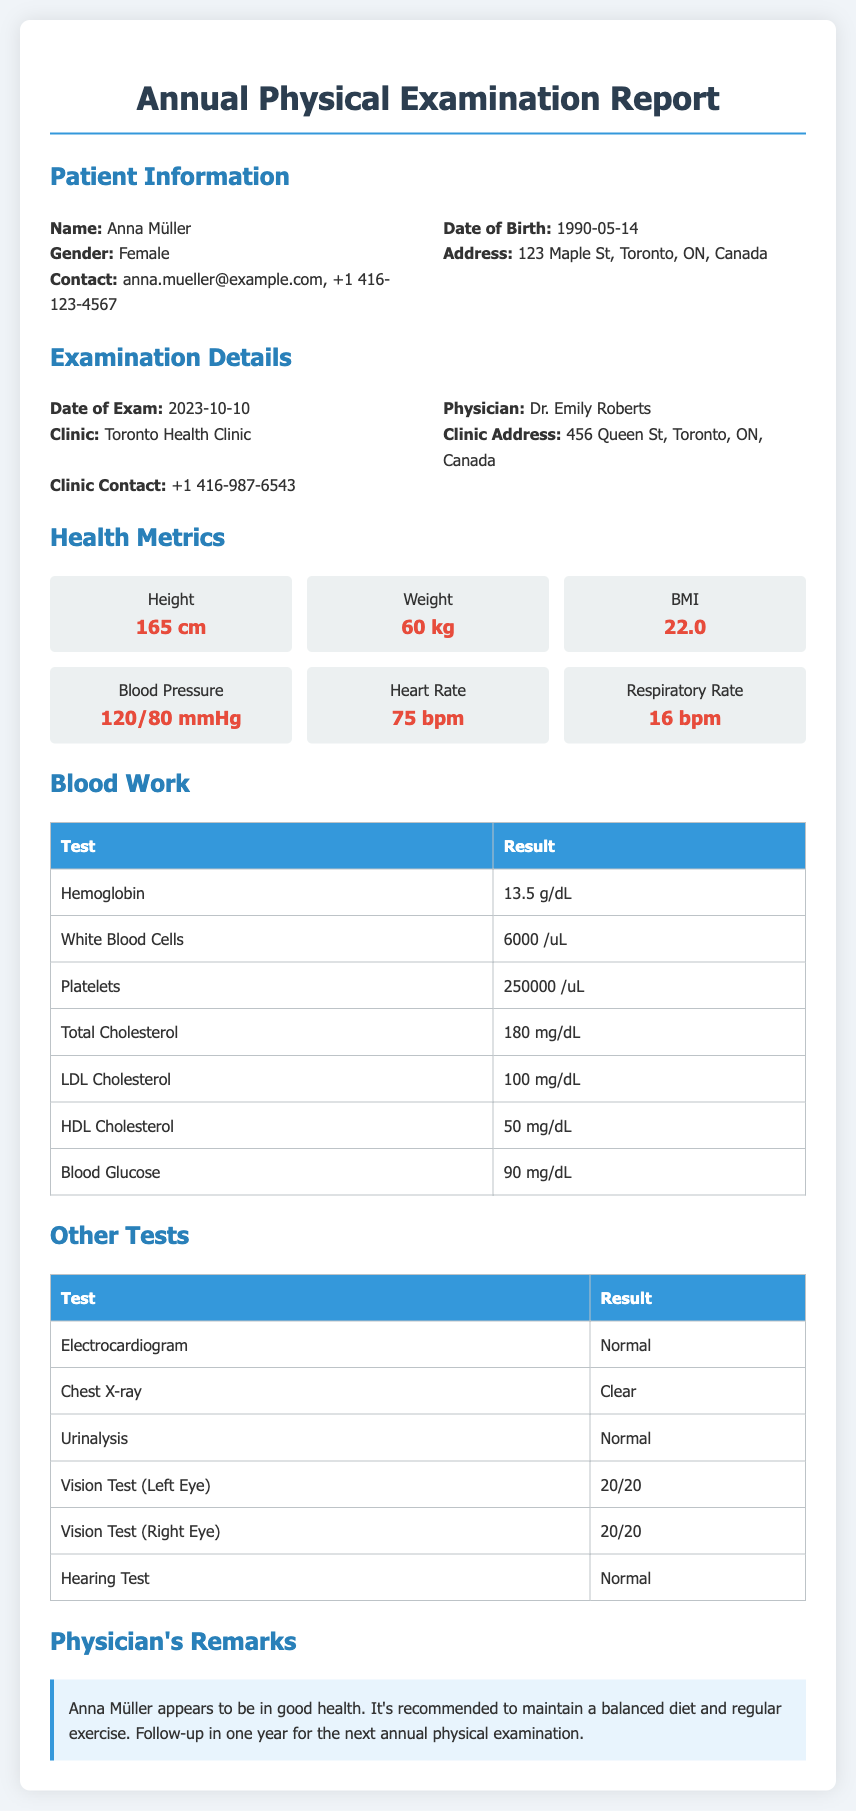What is the patient's name? The patient's name is specified in the document under patient information.
Answer: Anna Müller What is the date of the examination? The date of the examination is listed under examination details.
Answer: 2023-10-10 What is the patient's weight? The patient's weight can be found in the health metrics section of the document.
Answer: 60 kg What is the physician's name? The physician's name is provided in the examination details section.
Answer: Dr. Emily Roberts What is the patient's blood pressure reading? The blood pressure reading is included in the health metrics section.
Answer: 120/80 mmHg How many days until the patient's next follow-up? The next follow-up is scheduled for one year from the examination date. As of the examination date, it will be in 365 days.
Answer: 365 What is the patient's body mass index (BMI)? The BMI value is available in the health metrics section.
Answer: 22.0 What is the result of the urinalysis test? The result of the urinalysis can be found in the other tests section.
Answer: Normal Was the hearing test normal? The outcome of the hearing test is listed in the other tests section.
Answer: Normal What is the patient's cholesterol level? The total cholesterol level result is mentioned in the blood work table.
Answer: 180 mg/dL 